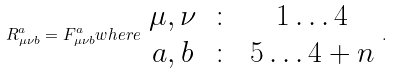Convert formula to latex. <formula><loc_0><loc_0><loc_500><loc_500>R _ { \mu \nu b } ^ { a } = F _ { \mu \nu b } ^ { a } w h e r e \begin{array} { c c c } \mu , \nu & \colon & 1 \dots 4 \\ a , b & \colon & 5 \dots 4 + n \end{array} .</formula> 